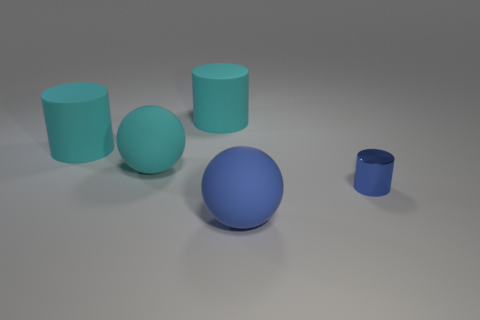Does the rubber cylinder to the left of the big cyan sphere have the same color as the cylinder that is to the right of the large blue matte thing?
Make the answer very short. No. Are there fewer tiny cylinders that are on the left side of the blue matte object than large cylinders?
Ensure brevity in your answer.  Yes. What number of objects are either large matte things or cylinders on the left side of the large blue rubber object?
Offer a terse response. 4. What is the color of the other large sphere that is the same material as the cyan ball?
Offer a terse response. Blue. What number of objects are either big blue matte objects or big cyan rubber cylinders?
Provide a short and direct response. 3. There is another ball that is the same size as the cyan sphere; what color is it?
Your answer should be very brief. Blue. How many things are either blue things that are to the right of the big blue thing or big blue spheres?
Your answer should be very brief. 2. How many other objects are the same size as the blue ball?
Ensure brevity in your answer.  3. There is a rubber thing in front of the big cyan ball; what is its size?
Offer a terse response. Large. What is the shape of the large blue thing that is made of the same material as the cyan sphere?
Your response must be concise. Sphere. 